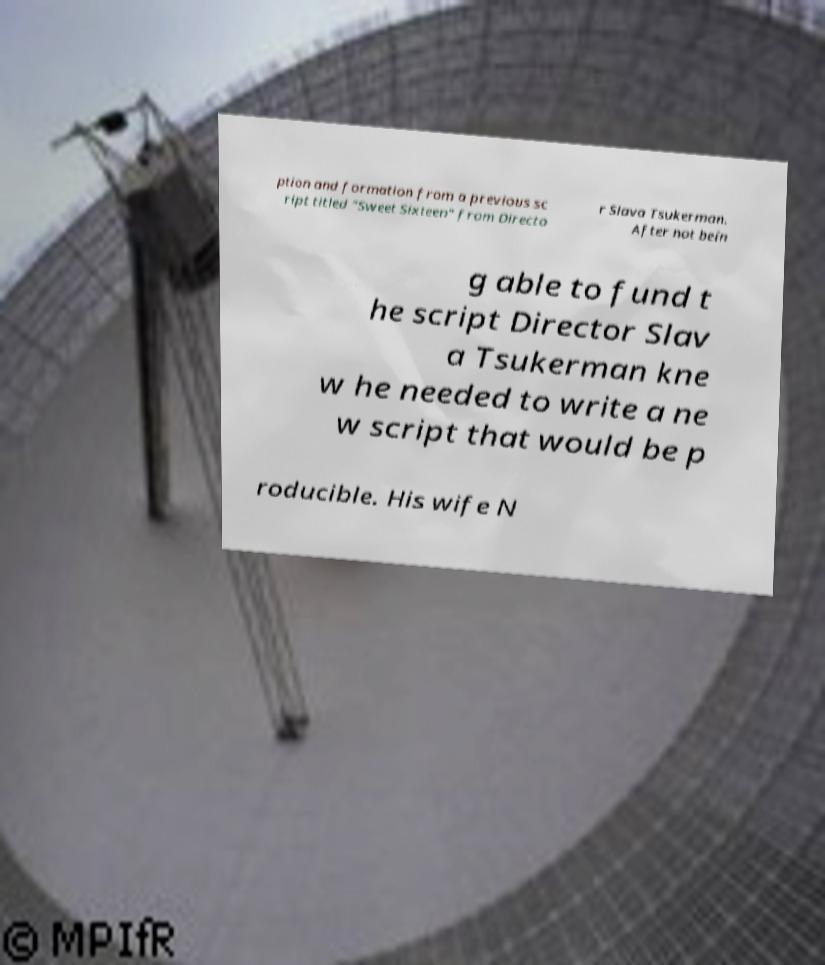For documentation purposes, I need the text within this image transcribed. Could you provide that? ption and formation from a previous sc ript titled "Sweet Sixteen" from Directo r Slava Tsukerman. After not bein g able to fund t he script Director Slav a Tsukerman kne w he needed to write a ne w script that would be p roducible. His wife N 